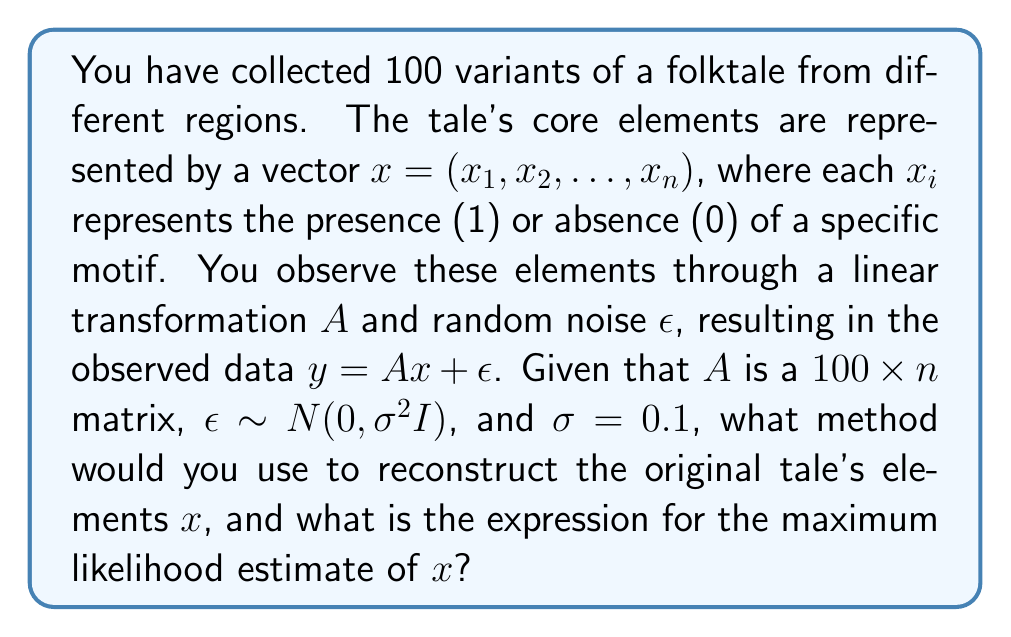Show me your answer to this math problem. To solve this inverse problem and reconstruct the original folktale's elements, we can use the method of Tikhonov regularization, also known as ridge regression. This method is particularly useful when dealing with ill-posed problems or when the matrix $A$ might be ill-conditioned.

Step 1: Formulate the problem
We have the linear model: $y = Ax + \epsilon$, where $\epsilon \sim N(0, \sigma^2I)$

Step 2: Define the likelihood function
The likelihood function is:
$$L(x|y) = \frac{1}{(2\pi\sigma^2)^{m/2}} \exp\left(-\frac{1}{2\sigma^2}||y - Ax||^2\right)$$
where $m = 100$ is the number of observations.

Step 3: Take the negative log-likelihood
$$-\log L(x|y) = \frac{m}{2}\log(2\pi\sigma^2) + \frac{1}{2\sigma^2}||y - Ax||^2$$

Step 4: Add regularization term
To stabilize the solution, we add a regularization term:
$$J(x) = \frac{1}{2\sigma^2}||y - Ax||^2 + \lambda||x||^2$$
where $\lambda > 0$ is the regularization parameter.

Step 5: Find the minimum of $J(x)$
To find the minimum, we set the gradient to zero:
$$\nabla J(x) = -\frac{1}{\sigma^2}A^T(y - Ax) + 2\lambda x = 0$$

Step 6: Solve for x
$$(A^TA + \lambda\sigma^2I)x = A^Ty$$

Therefore, the maximum likelihood estimate of $x$ is:
$$\hat{x} = (A^TA + \lambda\sigma^2I)^{-1}A^Ty$$
Answer: Tikhonov regularization; $\hat{x} = (A^TA + \lambda\sigma^2I)^{-1}A^Ty$ 